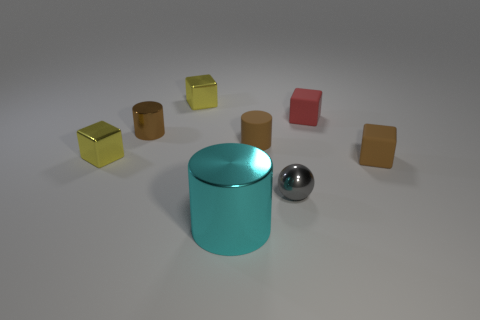Are there an equal number of yellow shiny objects and small rubber balls?
Provide a succinct answer. No. How many objects are on the left side of the small gray object and behind the large cyan cylinder?
Keep it short and to the point. 4. There is a yellow thing behind the tiny brown cylinder to the left of the matte object that is on the left side of the tiny red matte thing; what is its material?
Make the answer very short. Metal. How many big cylinders have the same material as the large cyan object?
Ensure brevity in your answer.  0. The small metal object that is the same color as the small rubber cylinder is what shape?
Offer a terse response. Cylinder. What is the shape of the red object that is the same size as the gray shiny object?
Offer a very short reply. Cube. There is a cube that is the same color as the small rubber cylinder; what is its material?
Ensure brevity in your answer.  Rubber. There is a big shiny object; are there any tiny yellow things on the right side of it?
Provide a short and direct response. No. Are there any other metallic objects of the same shape as the red object?
Make the answer very short. Yes. Does the tiny brown rubber thing right of the small gray ball have the same shape as the thing that is behind the red object?
Your response must be concise. Yes. 